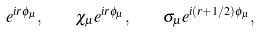Convert formula to latex. <formula><loc_0><loc_0><loc_500><loc_500>e ^ { i r \phi _ { \mu } } , \quad \chi _ { \mu } e ^ { i r \phi _ { \mu } } , \quad \sigma _ { \mu } e ^ { i ( r + 1 / 2 ) \phi _ { \mu } } ,</formula> 